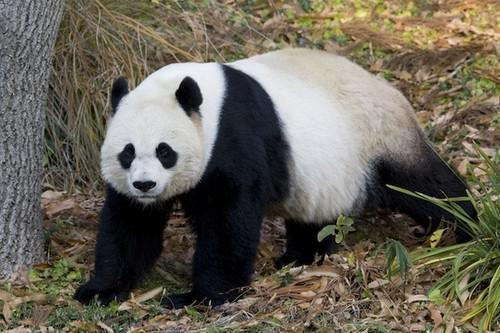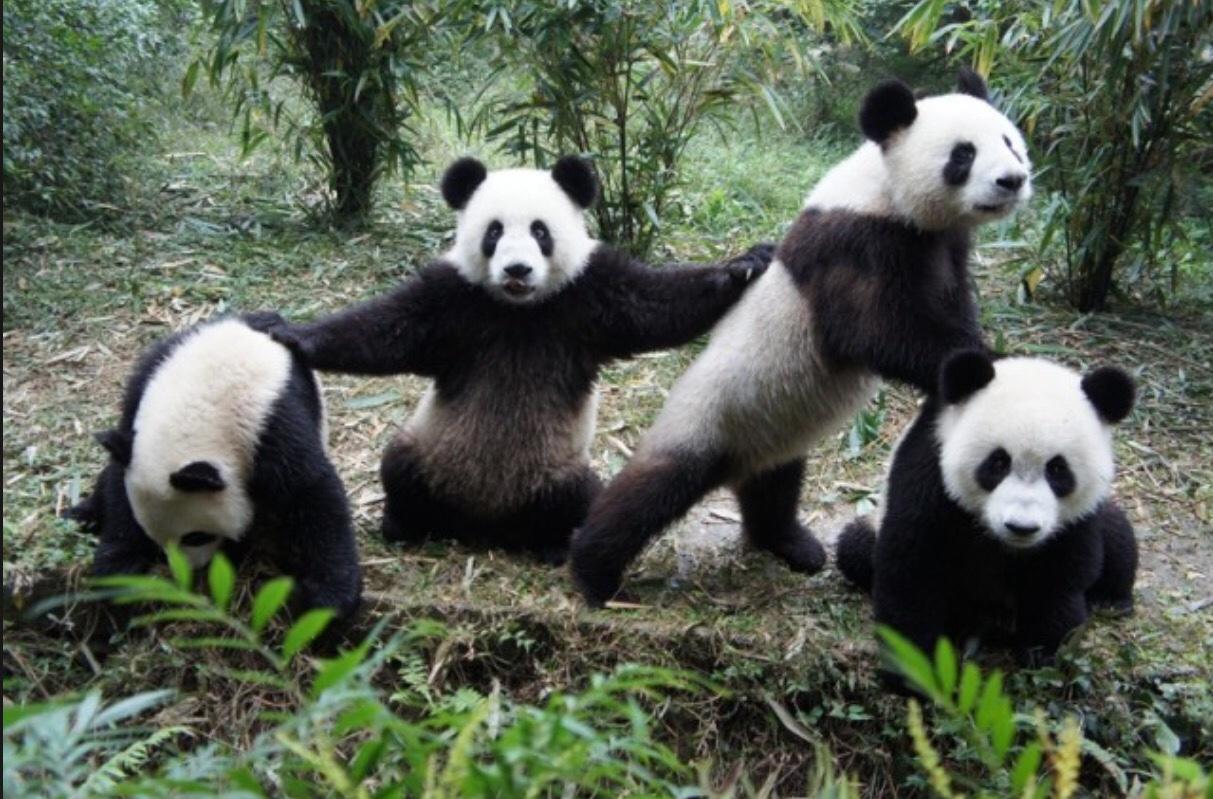The first image is the image on the left, the second image is the image on the right. Analyze the images presented: Is the assertion "An image shows one open-mouthed panda clutching a leafless stalk." valid? Answer yes or no. No. 